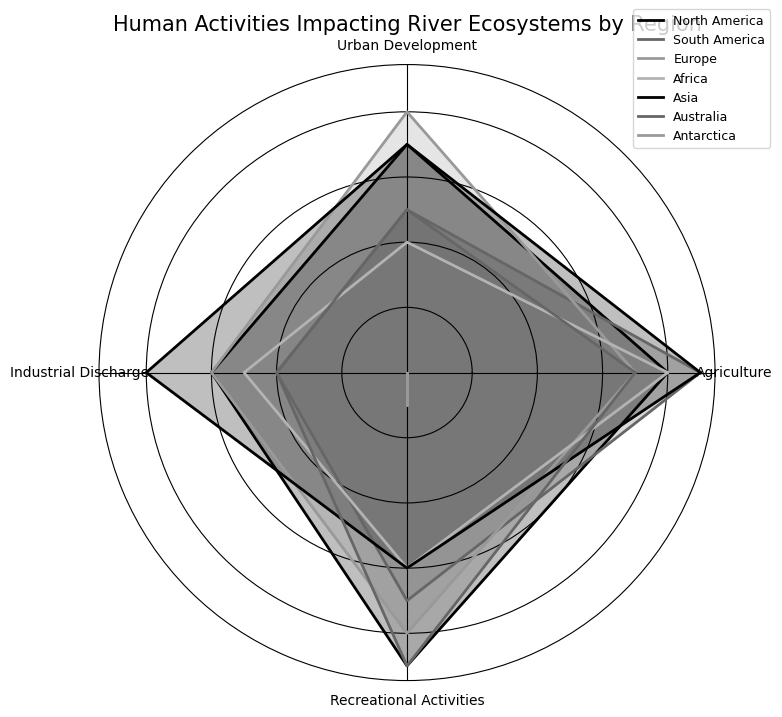Which region has the highest impact from agricultural activities? Look for the region with the highest value in the Agriculture category. South America and Asia both have the highest value of 9.
Answer: South America and Asia Which region shows the least recreational activities impacting the river ecosystems? Identify the region with the lowest value in the Recreational Activities category. Antarctica has the lowest value of 1.
Answer: Antarctica Which regions have equal impacts from urban development activities? Compare the values in the Urban Development category and find regions with the same value. North America and Asia both have a value of 7.
Answer: North America and Asia What is the average impact score from industrial discharge across all regions? Sum the Industrial Discharge values (6+4+6+5+8+4+0) and divide by the number of regions (7). (6+4+6+5+8+4+0)=33; 33/7 ≈ 4.71
Answer: Approximately 4.71 Which region has the smallest overall impact on river ecosystems? Sum the values across all categories for each region and compare the totals. Antarctica has the smallest sum (0+0+0+1=1).
Answer: Antarctica Compare the impact of North America and Europe in recreational activities. Which region has a higher impact? Compare the values in the Recreational Activities category for North America and Europe. North America has 9, and Europe has 8.
Answer: North America How does the impact from industrial discharge in Asia compare to that in South America? Compare the values in the Industrial Discharge category for Asia and South America. Asia has 8, and South America has 4.
Answer: Asia has a higher impact What is the combined impact score from urban development and agriculture in Africa? Sum the values of Urban Development and Agriculture for Africa. 4 (Urban Development) + 8 (Agriculture) = 12
Answer: 12 Which region has the highest total impact across all categories? Sum the values across all categories for each region and compare the totals. The highest total sum is for Asia (9+7+8+6=30).
Answer: Asia How does Australia compare to Antarctica in terms of total impact across all categories? Sum the values across all categories for each region and compare the totals. Australia: 7+5+4+9=25; Antarctica: 0+0+0+1=1; Australia's total is higher.
Answer: Australia has a higher total impact 